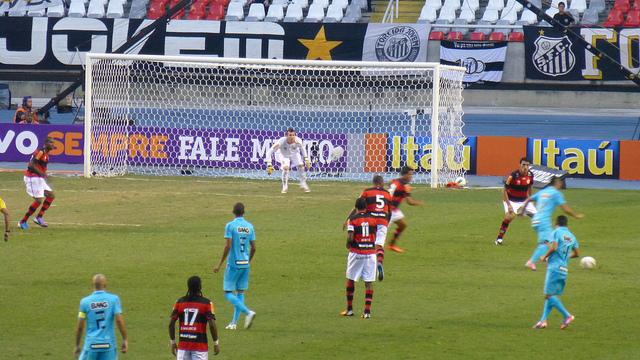What sport is this?
Keep it brief. Soccer. Is the game live?
Be succinct. Yes. What colors are the uniforms?
Short answer required. Blue and red. 